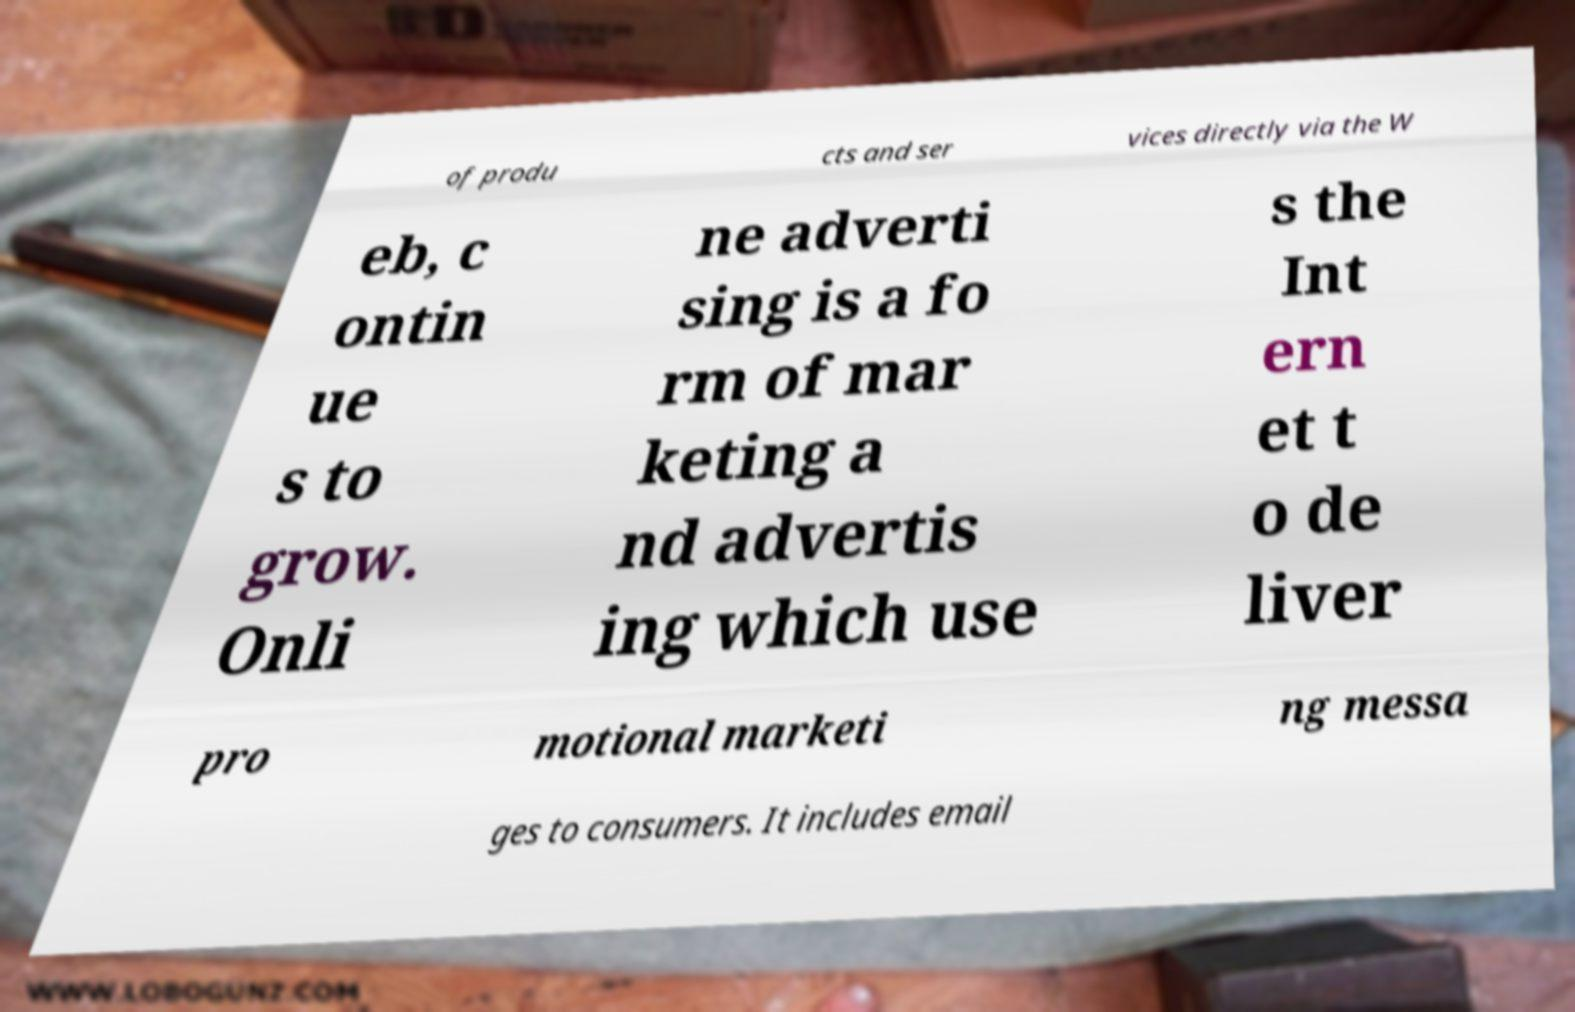Please read and relay the text visible in this image. What does it say? of produ cts and ser vices directly via the W eb, c ontin ue s to grow. Onli ne adverti sing is a fo rm of mar keting a nd advertis ing which use s the Int ern et t o de liver pro motional marketi ng messa ges to consumers. It includes email 